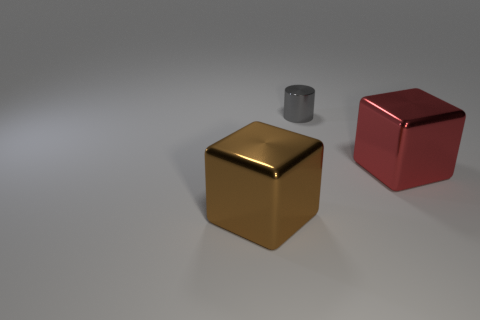Add 1 big red objects. How many objects exist? 4 Subtract all blocks. How many objects are left? 1 Add 3 tiny cylinders. How many tiny cylinders exist? 4 Subtract 0 gray spheres. How many objects are left? 3 Subtract all small cylinders. Subtract all large red shiny objects. How many objects are left? 1 Add 1 large metal things. How many large metal things are left? 3 